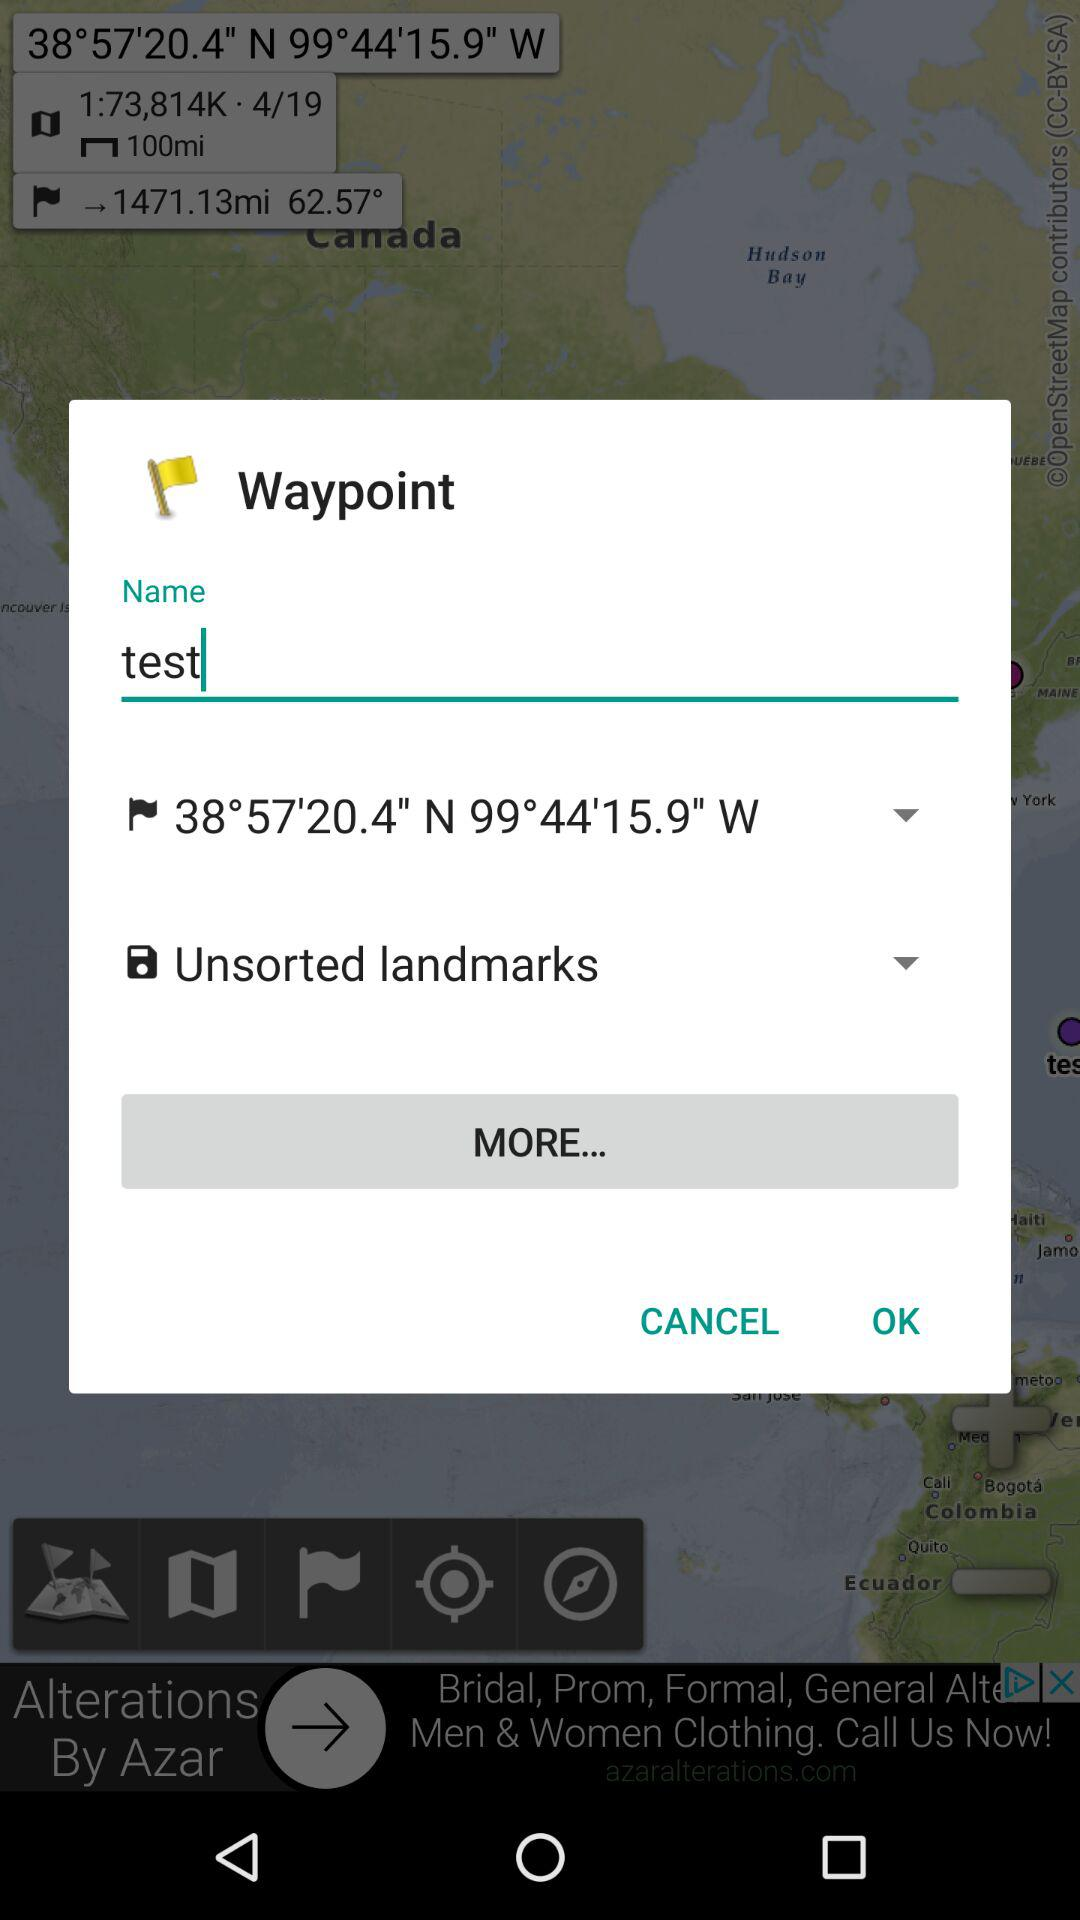What's the save title? The save title is "test". 